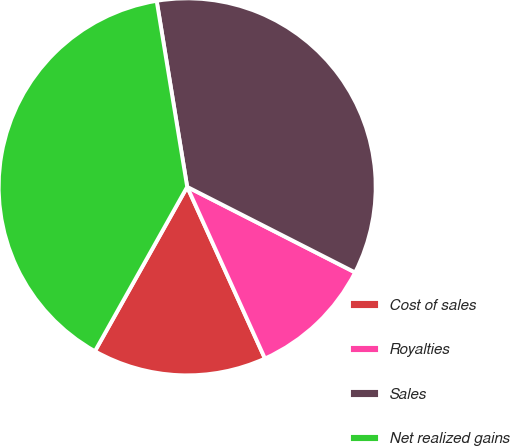Convert chart to OTSL. <chart><loc_0><loc_0><loc_500><loc_500><pie_chart><fcel>Cost of sales<fcel>Royalties<fcel>Sales<fcel>Net realized gains<nl><fcel>14.91%<fcel>10.73%<fcel>35.09%<fcel>39.27%<nl></chart> 